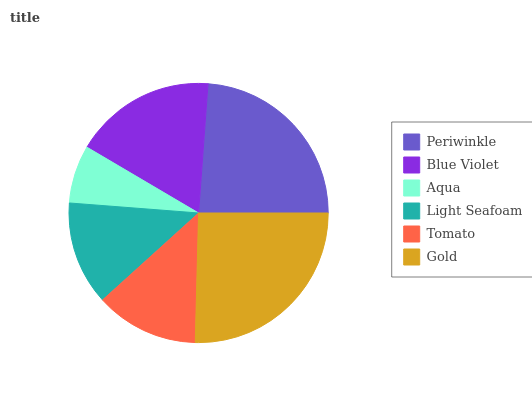Is Aqua the minimum?
Answer yes or no. Yes. Is Gold the maximum?
Answer yes or no. Yes. Is Blue Violet the minimum?
Answer yes or no. No. Is Blue Violet the maximum?
Answer yes or no. No. Is Periwinkle greater than Blue Violet?
Answer yes or no. Yes. Is Blue Violet less than Periwinkle?
Answer yes or no. Yes. Is Blue Violet greater than Periwinkle?
Answer yes or no. No. Is Periwinkle less than Blue Violet?
Answer yes or no. No. Is Blue Violet the high median?
Answer yes or no. Yes. Is Light Seafoam the low median?
Answer yes or no. Yes. Is Tomato the high median?
Answer yes or no. No. Is Blue Violet the low median?
Answer yes or no. No. 